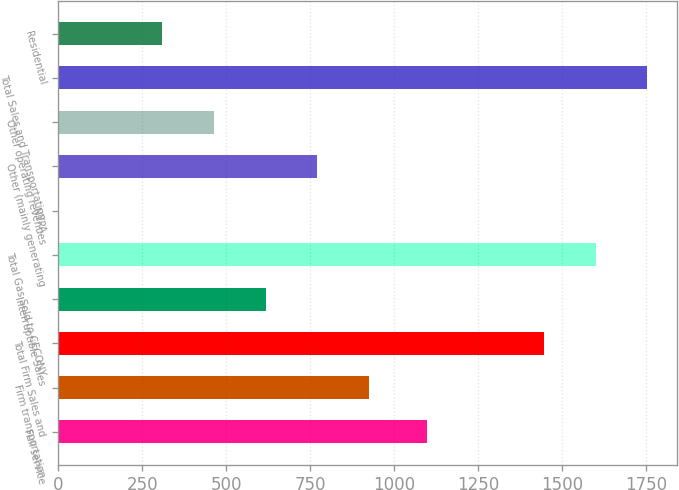Convert chart. <chart><loc_0><loc_0><loc_500><loc_500><bar_chart><fcel>Full service<fcel>Firm transportation<fcel>Total Firm Sales and<fcel>Interruptible Sales<fcel>Total Gas Sold to CECONY<fcel>NYPA<fcel>Other (mainly generating<fcel>Other operating revenues<fcel>Total Sales and Transportation<fcel>Residential<nl><fcel>1099<fcel>925.4<fcel>1446<fcel>617.6<fcel>1599.9<fcel>2<fcel>771.5<fcel>463.7<fcel>1753.8<fcel>309.8<nl></chart> 